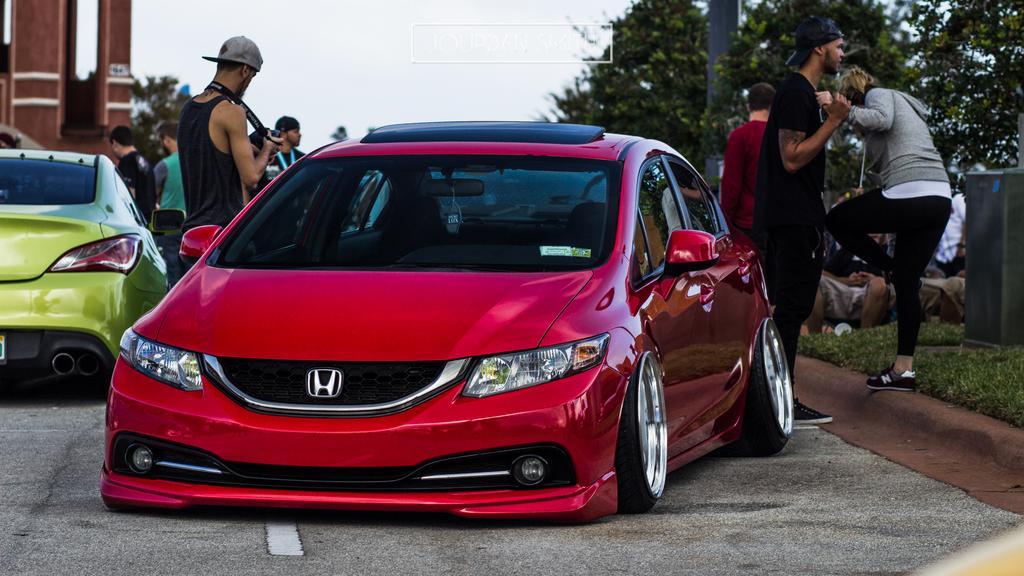In one or two sentences, can you explain what this image depicts? In this picture there are cars on the road and there is a man standing and holding the camera. At the back there are group of people standing and there are two people sitting. On the right side of the image there is a dustbin and there is a pole and there are trees. On the left side of the image there is a building. At the top there is sky. At the bottom there is a road and there is grass. 